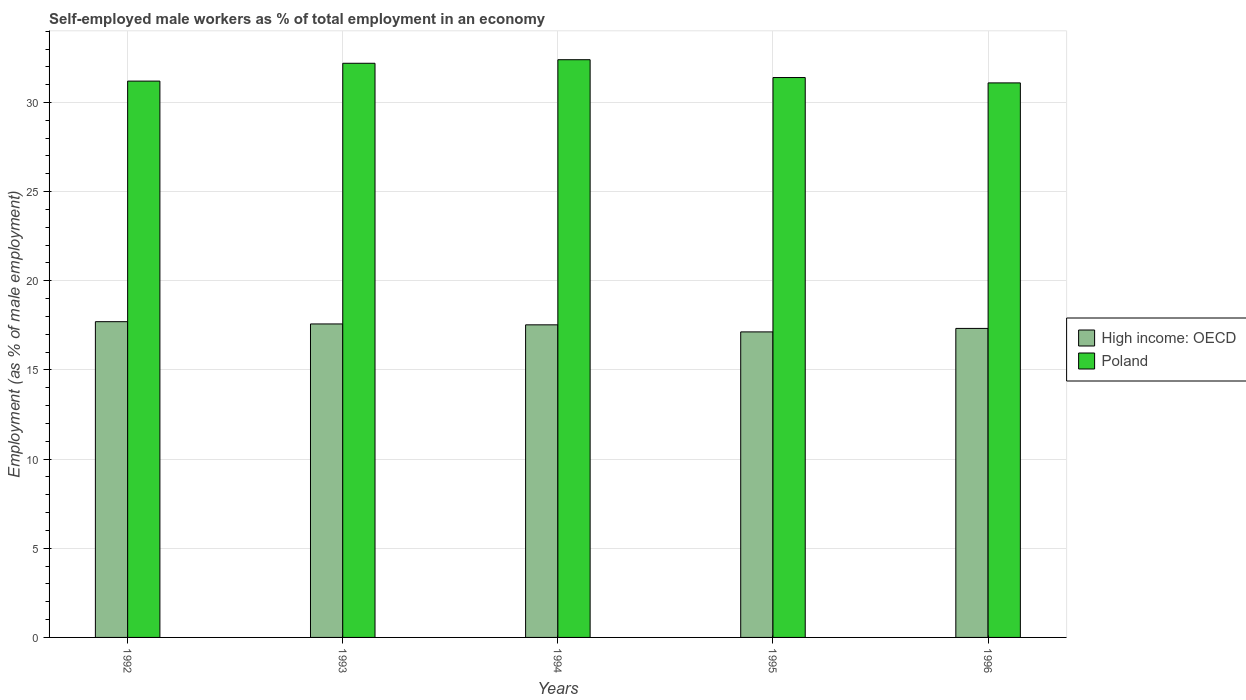How many different coloured bars are there?
Keep it short and to the point. 2. Are the number of bars per tick equal to the number of legend labels?
Ensure brevity in your answer.  Yes. Are the number of bars on each tick of the X-axis equal?
Offer a terse response. Yes. How many bars are there on the 4th tick from the right?
Make the answer very short. 2. What is the label of the 2nd group of bars from the left?
Keep it short and to the point. 1993. What is the percentage of self-employed male workers in Poland in 1995?
Offer a very short reply. 31.4. Across all years, what is the maximum percentage of self-employed male workers in High income: OECD?
Your answer should be compact. 17.71. Across all years, what is the minimum percentage of self-employed male workers in High income: OECD?
Provide a short and direct response. 17.14. In which year was the percentage of self-employed male workers in Poland maximum?
Your answer should be compact. 1994. In which year was the percentage of self-employed male workers in Poland minimum?
Make the answer very short. 1996. What is the total percentage of self-employed male workers in High income: OECD in the graph?
Make the answer very short. 87.29. What is the difference between the percentage of self-employed male workers in Poland in 1992 and that in 1996?
Offer a terse response. 0.1. What is the difference between the percentage of self-employed male workers in High income: OECD in 1993 and the percentage of self-employed male workers in Poland in 1996?
Make the answer very short. -13.52. What is the average percentage of self-employed male workers in High income: OECD per year?
Offer a very short reply. 17.46. In the year 1992, what is the difference between the percentage of self-employed male workers in High income: OECD and percentage of self-employed male workers in Poland?
Your answer should be compact. -13.49. In how many years, is the percentage of self-employed male workers in High income: OECD greater than 11 %?
Give a very brief answer. 5. What is the ratio of the percentage of self-employed male workers in Poland in 1993 to that in 1995?
Offer a very short reply. 1.03. Is the percentage of self-employed male workers in High income: OECD in 1995 less than that in 1996?
Give a very brief answer. Yes. Is the difference between the percentage of self-employed male workers in High income: OECD in 1995 and 1996 greater than the difference between the percentage of self-employed male workers in Poland in 1995 and 1996?
Offer a very short reply. No. What is the difference between the highest and the second highest percentage of self-employed male workers in High income: OECD?
Ensure brevity in your answer.  0.13. What is the difference between the highest and the lowest percentage of self-employed male workers in Poland?
Your answer should be compact. 1.3. Is the sum of the percentage of self-employed male workers in High income: OECD in 1994 and 1995 greater than the maximum percentage of self-employed male workers in Poland across all years?
Your answer should be compact. Yes. How many years are there in the graph?
Provide a short and direct response. 5. What is the difference between two consecutive major ticks on the Y-axis?
Ensure brevity in your answer.  5. Are the values on the major ticks of Y-axis written in scientific E-notation?
Your response must be concise. No. Does the graph contain any zero values?
Keep it short and to the point. No. What is the title of the graph?
Your answer should be compact. Self-employed male workers as % of total employment in an economy. What is the label or title of the X-axis?
Make the answer very short. Years. What is the label or title of the Y-axis?
Offer a very short reply. Employment (as % of male employment). What is the Employment (as % of male employment) in High income: OECD in 1992?
Your answer should be very brief. 17.71. What is the Employment (as % of male employment) of Poland in 1992?
Offer a terse response. 31.2. What is the Employment (as % of male employment) in High income: OECD in 1993?
Offer a very short reply. 17.58. What is the Employment (as % of male employment) in Poland in 1993?
Your answer should be very brief. 32.2. What is the Employment (as % of male employment) in High income: OECD in 1994?
Your answer should be compact. 17.53. What is the Employment (as % of male employment) of Poland in 1994?
Your answer should be compact. 32.4. What is the Employment (as % of male employment) in High income: OECD in 1995?
Provide a short and direct response. 17.14. What is the Employment (as % of male employment) of Poland in 1995?
Your answer should be very brief. 31.4. What is the Employment (as % of male employment) in High income: OECD in 1996?
Give a very brief answer. 17.33. What is the Employment (as % of male employment) of Poland in 1996?
Offer a terse response. 31.1. Across all years, what is the maximum Employment (as % of male employment) of High income: OECD?
Offer a terse response. 17.71. Across all years, what is the maximum Employment (as % of male employment) in Poland?
Your answer should be compact. 32.4. Across all years, what is the minimum Employment (as % of male employment) in High income: OECD?
Keep it short and to the point. 17.14. Across all years, what is the minimum Employment (as % of male employment) in Poland?
Keep it short and to the point. 31.1. What is the total Employment (as % of male employment) of High income: OECD in the graph?
Your response must be concise. 87.29. What is the total Employment (as % of male employment) in Poland in the graph?
Your answer should be very brief. 158.3. What is the difference between the Employment (as % of male employment) in High income: OECD in 1992 and that in 1993?
Your answer should be very brief. 0.13. What is the difference between the Employment (as % of male employment) in High income: OECD in 1992 and that in 1994?
Your answer should be very brief. 0.18. What is the difference between the Employment (as % of male employment) in High income: OECD in 1992 and that in 1995?
Your answer should be compact. 0.57. What is the difference between the Employment (as % of male employment) in Poland in 1992 and that in 1995?
Give a very brief answer. -0.2. What is the difference between the Employment (as % of male employment) of High income: OECD in 1992 and that in 1996?
Your answer should be compact. 0.38. What is the difference between the Employment (as % of male employment) in Poland in 1992 and that in 1996?
Ensure brevity in your answer.  0.1. What is the difference between the Employment (as % of male employment) in High income: OECD in 1993 and that in 1994?
Keep it short and to the point. 0.05. What is the difference between the Employment (as % of male employment) of High income: OECD in 1993 and that in 1995?
Your answer should be very brief. 0.45. What is the difference between the Employment (as % of male employment) of High income: OECD in 1993 and that in 1996?
Give a very brief answer. 0.25. What is the difference between the Employment (as % of male employment) in Poland in 1993 and that in 1996?
Offer a very short reply. 1.1. What is the difference between the Employment (as % of male employment) in High income: OECD in 1994 and that in 1995?
Offer a very short reply. 0.4. What is the difference between the Employment (as % of male employment) of Poland in 1994 and that in 1995?
Keep it short and to the point. 1. What is the difference between the Employment (as % of male employment) in High income: OECD in 1994 and that in 1996?
Offer a very short reply. 0.2. What is the difference between the Employment (as % of male employment) in Poland in 1994 and that in 1996?
Provide a succinct answer. 1.3. What is the difference between the Employment (as % of male employment) in High income: OECD in 1995 and that in 1996?
Keep it short and to the point. -0.19. What is the difference between the Employment (as % of male employment) in Poland in 1995 and that in 1996?
Your answer should be very brief. 0.3. What is the difference between the Employment (as % of male employment) in High income: OECD in 1992 and the Employment (as % of male employment) in Poland in 1993?
Provide a succinct answer. -14.49. What is the difference between the Employment (as % of male employment) of High income: OECD in 1992 and the Employment (as % of male employment) of Poland in 1994?
Your response must be concise. -14.69. What is the difference between the Employment (as % of male employment) in High income: OECD in 1992 and the Employment (as % of male employment) in Poland in 1995?
Offer a terse response. -13.69. What is the difference between the Employment (as % of male employment) of High income: OECD in 1992 and the Employment (as % of male employment) of Poland in 1996?
Your answer should be compact. -13.39. What is the difference between the Employment (as % of male employment) of High income: OECD in 1993 and the Employment (as % of male employment) of Poland in 1994?
Keep it short and to the point. -14.82. What is the difference between the Employment (as % of male employment) in High income: OECD in 1993 and the Employment (as % of male employment) in Poland in 1995?
Offer a terse response. -13.82. What is the difference between the Employment (as % of male employment) in High income: OECD in 1993 and the Employment (as % of male employment) in Poland in 1996?
Offer a terse response. -13.52. What is the difference between the Employment (as % of male employment) of High income: OECD in 1994 and the Employment (as % of male employment) of Poland in 1995?
Your response must be concise. -13.87. What is the difference between the Employment (as % of male employment) of High income: OECD in 1994 and the Employment (as % of male employment) of Poland in 1996?
Give a very brief answer. -13.57. What is the difference between the Employment (as % of male employment) of High income: OECD in 1995 and the Employment (as % of male employment) of Poland in 1996?
Your response must be concise. -13.96. What is the average Employment (as % of male employment) in High income: OECD per year?
Keep it short and to the point. 17.46. What is the average Employment (as % of male employment) in Poland per year?
Your response must be concise. 31.66. In the year 1992, what is the difference between the Employment (as % of male employment) in High income: OECD and Employment (as % of male employment) in Poland?
Make the answer very short. -13.49. In the year 1993, what is the difference between the Employment (as % of male employment) of High income: OECD and Employment (as % of male employment) of Poland?
Give a very brief answer. -14.62. In the year 1994, what is the difference between the Employment (as % of male employment) of High income: OECD and Employment (as % of male employment) of Poland?
Your response must be concise. -14.87. In the year 1995, what is the difference between the Employment (as % of male employment) of High income: OECD and Employment (as % of male employment) of Poland?
Make the answer very short. -14.26. In the year 1996, what is the difference between the Employment (as % of male employment) of High income: OECD and Employment (as % of male employment) of Poland?
Keep it short and to the point. -13.77. What is the ratio of the Employment (as % of male employment) of High income: OECD in 1992 to that in 1993?
Your response must be concise. 1.01. What is the ratio of the Employment (as % of male employment) in Poland in 1992 to that in 1993?
Provide a short and direct response. 0.97. What is the ratio of the Employment (as % of male employment) in High income: OECD in 1992 to that in 1994?
Give a very brief answer. 1.01. What is the ratio of the Employment (as % of male employment) in Poland in 1992 to that in 1994?
Make the answer very short. 0.96. What is the ratio of the Employment (as % of male employment) in High income: OECD in 1992 to that in 1995?
Make the answer very short. 1.03. What is the ratio of the Employment (as % of male employment) of Poland in 1992 to that in 1995?
Keep it short and to the point. 0.99. What is the ratio of the Employment (as % of male employment) in High income: OECD in 1992 to that in 1996?
Keep it short and to the point. 1.02. What is the ratio of the Employment (as % of male employment) of Poland in 1992 to that in 1996?
Offer a terse response. 1. What is the ratio of the Employment (as % of male employment) in Poland in 1993 to that in 1995?
Offer a terse response. 1.03. What is the ratio of the Employment (as % of male employment) of High income: OECD in 1993 to that in 1996?
Your response must be concise. 1.01. What is the ratio of the Employment (as % of male employment) of Poland in 1993 to that in 1996?
Keep it short and to the point. 1.04. What is the ratio of the Employment (as % of male employment) of High income: OECD in 1994 to that in 1995?
Provide a short and direct response. 1.02. What is the ratio of the Employment (as % of male employment) in Poland in 1994 to that in 1995?
Your response must be concise. 1.03. What is the ratio of the Employment (as % of male employment) of High income: OECD in 1994 to that in 1996?
Provide a succinct answer. 1.01. What is the ratio of the Employment (as % of male employment) of Poland in 1994 to that in 1996?
Your answer should be very brief. 1.04. What is the ratio of the Employment (as % of male employment) in High income: OECD in 1995 to that in 1996?
Your answer should be very brief. 0.99. What is the ratio of the Employment (as % of male employment) in Poland in 1995 to that in 1996?
Offer a very short reply. 1.01. What is the difference between the highest and the second highest Employment (as % of male employment) of High income: OECD?
Your answer should be compact. 0.13. What is the difference between the highest and the second highest Employment (as % of male employment) in Poland?
Keep it short and to the point. 0.2. What is the difference between the highest and the lowest Employment (as % of male employment) of High income: OECD?
Your response must be concise. 0.57. What is the difference between the highest and the lowest Employment (as % of male employment) of Poland?
Offer a terse response. 1.3. 